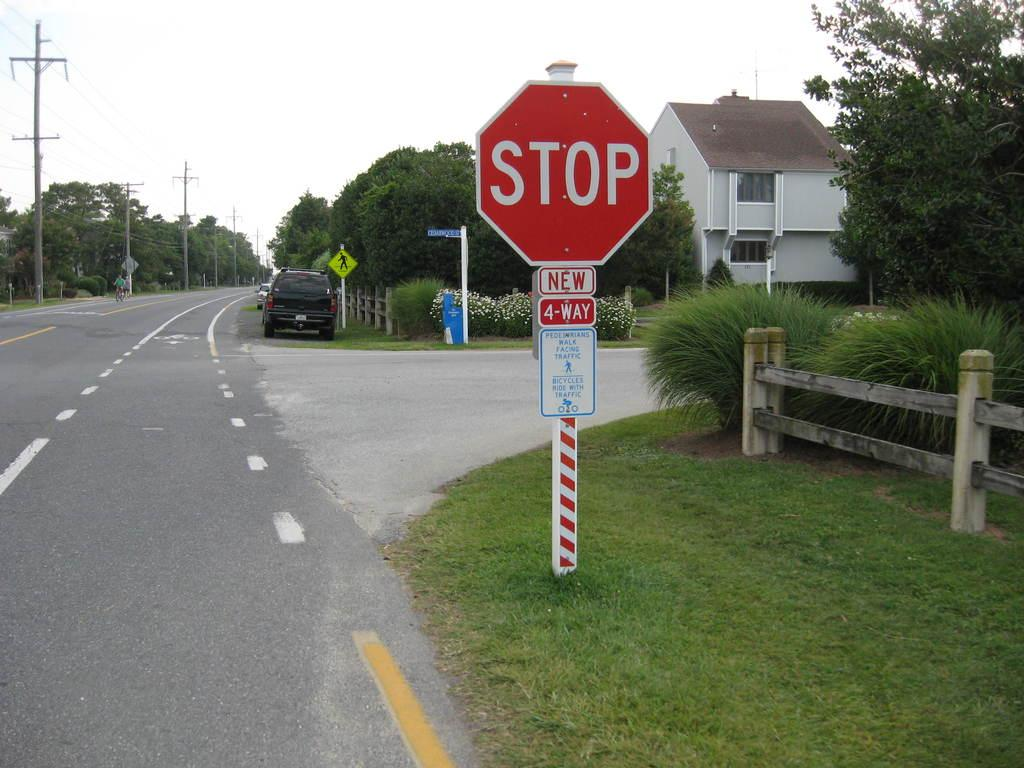<image>
Write a terse but informative summary of the picture. a stop sign that is in some grass near a building 